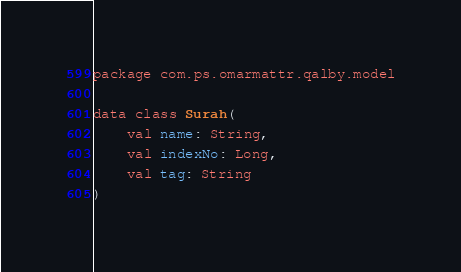<code> <loc_0><loc_0><loc_500><loc_500><_Kotlin_>package com.ps.omarmattr.qalby.model

data class Surah(
    val name: String,
    val indexNo: Long,
    val tag: String
)
</code> 